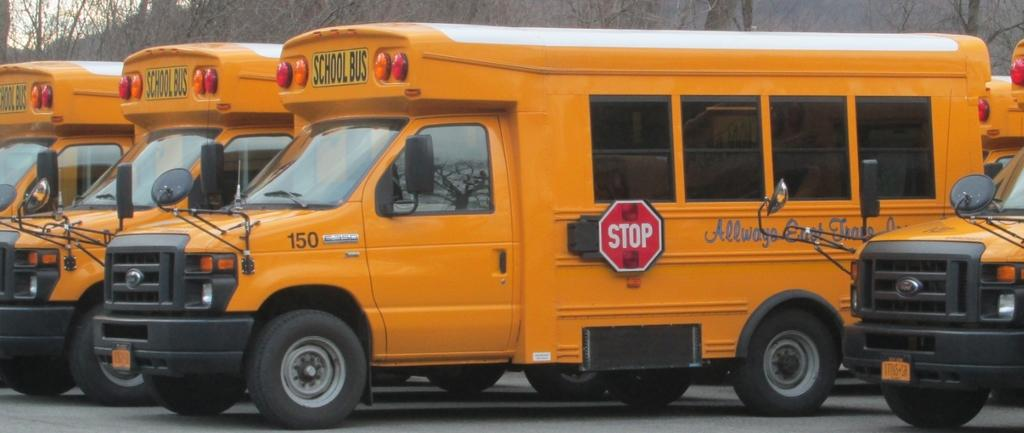What type of objects are present in the image? There are vehicles in the image. What is the color of the vehicles? The vehicles are orange in color. What can be seen in the background of the image? There are dried trees in the background of the image. What is the color of the sky in the image? The sky is white in color. What type of jar is visible in the image? There is no jar present in the image. 